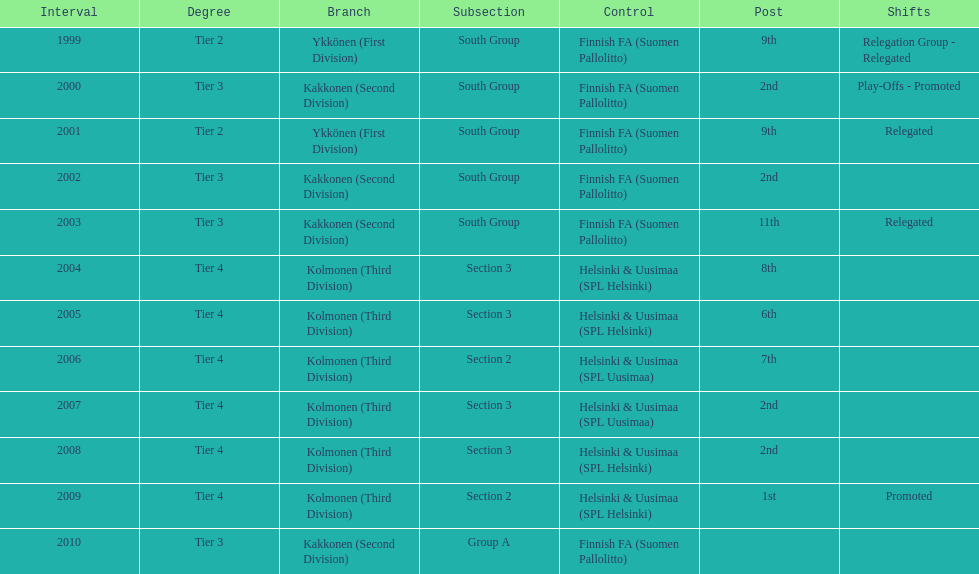Could you help me parse every detail presented in this table? {'header': ['Interval', 'Degree', 'Branch', 'Subsection', 'Control', 'Post', 'Shifts'], 'rows': [['1999', 'Tier 2', 'Ykkönen (First Division)', 'South Group', 'Finnish FA (Suomen Pallolitto)', '9th', 'Relegation Group - Relegated'], ['2000', 'Tier 3', 'Kakkonen (Second Division)', 'South Group', 'Finnish FA (Suomen Pallolitto)', '2nd', 'Play-Offs - Promoted'], ['2001', 'Tier 2', 'Ykkönen (First Division)', 'South Group', 'Finnish FA (Suomen Pallolitto)', '9th', 'Relegated'], ['2002', 'Tier 3', 'Kakkonen (Second Division)', 'South Group', 'Finnish FA (Suomen Pallolitto)', '2nd', ''], ['2003', 'Tier 3', 'Kakkonen (Second Division)', 'South Group', 'Finnish FA (Suomen Pallolitto)', '11th', 'Relegated'], ['2004', 'Tier 4', 'Kolmonen (Third Division)', 'Section 3', 'Helsinki & Uusimaa (SPL Helsinki)', '8th', ''], ['2005', 'Tier 4', 'Kolmonen (Third Division)', 'Section 3', 'Helsinki & Uusimaa (SPL Helsinki)', '6th', ''], ['2006', 'Tier 4', 'Kolmonen (Third Division)', 'Section 2', 'Helsinki & Uusimaa (SPL Uusimaa)', '7th', ''], ['2007', 'Tier 4', 'Kolmonen (Third Division)', 'Section 3', 'Helsinki & Uusimaa (SPL Uusimaa)', '2nd', ''], ['2008', 'Tier 4', 'Kolmonen (Third Division)', 'Section 3', 'Helsinki & Uusimaa (SPL Helsinki)', '2nd', ''], ['2009', 'Tier 4', 'Kolmonen (Third Division)', 'Section 2', 'Helsinki & Uusimaa (SPL Helsinki)', '1st', 'Promoted'], ['2010', 'Tier 3', 'Kakkonen (Second Division)', 'Group A', 'Finnish FA (Suomen Pallolitto)', '', '']]} What position did this team get after getting 9th place in 1999? 2nd. 